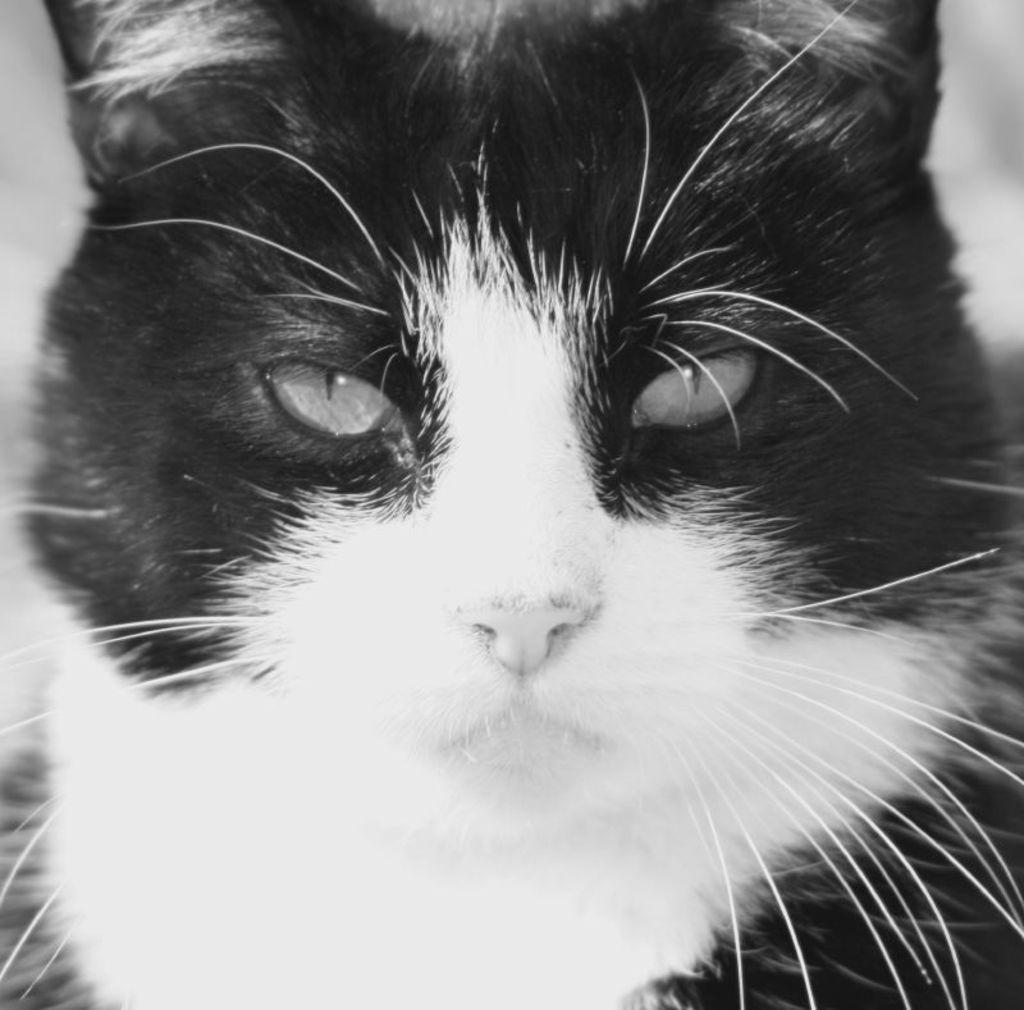What type of animal is in the image? There is a cat in the image. Can you describe the color of the cat? The cat is black and white in color. How does the cat's growth rate compare to that of a minute? The cat's growth rate cannot be compared to that of a minute, as the image only shows the cat at a specific moment in time and does not provide any information about its growth rate. 